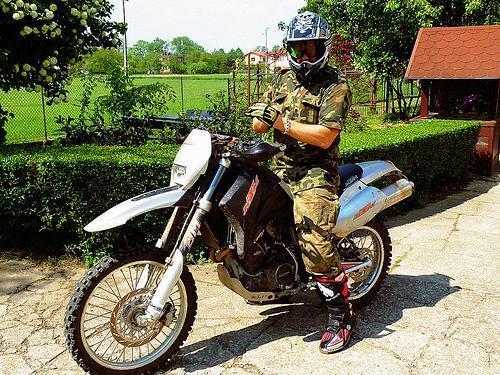How many helmets?
Give a very brief answer. 1. 